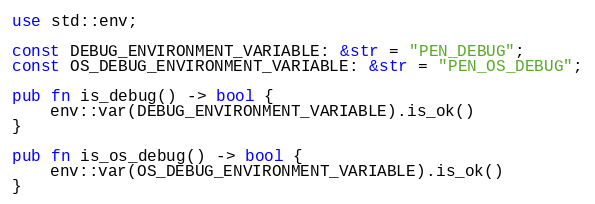<code> <loc_0><loc_0><loc_500><loc_500><_Rust_>use std::env;

const DEBUG_ENVIRONMENT_VARIABLE: &str = "PEN_DEBUG";
const OS_DEBUG_ENVIRONMENT_VARIABLE: &str = "PEN_OS_DEBUG";

pub fn is_debug() -> bool {
    env::var(DEBUG_ENVIRONMENT_VARIABLE).is_ok()
}

pub fn is_os_debug() -> bool {
    env::var(OS_DEBUG_ENVIRONMENT_VARIABLE).is_ok()
}
</code> 